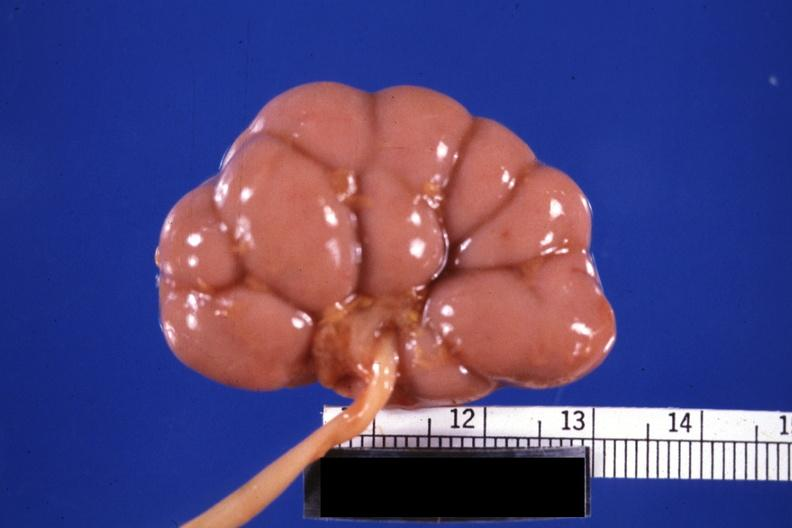s fetal lobulation present?
Answer the question using a single word or phrase. Yes 